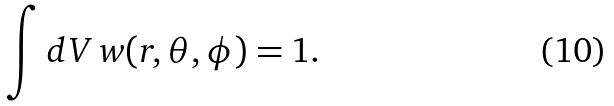<formula> <loc_0><loc_0><loc_500><loc_500>\int d V \, w ( r , \theta , \phi ) = 1 .</formula> 